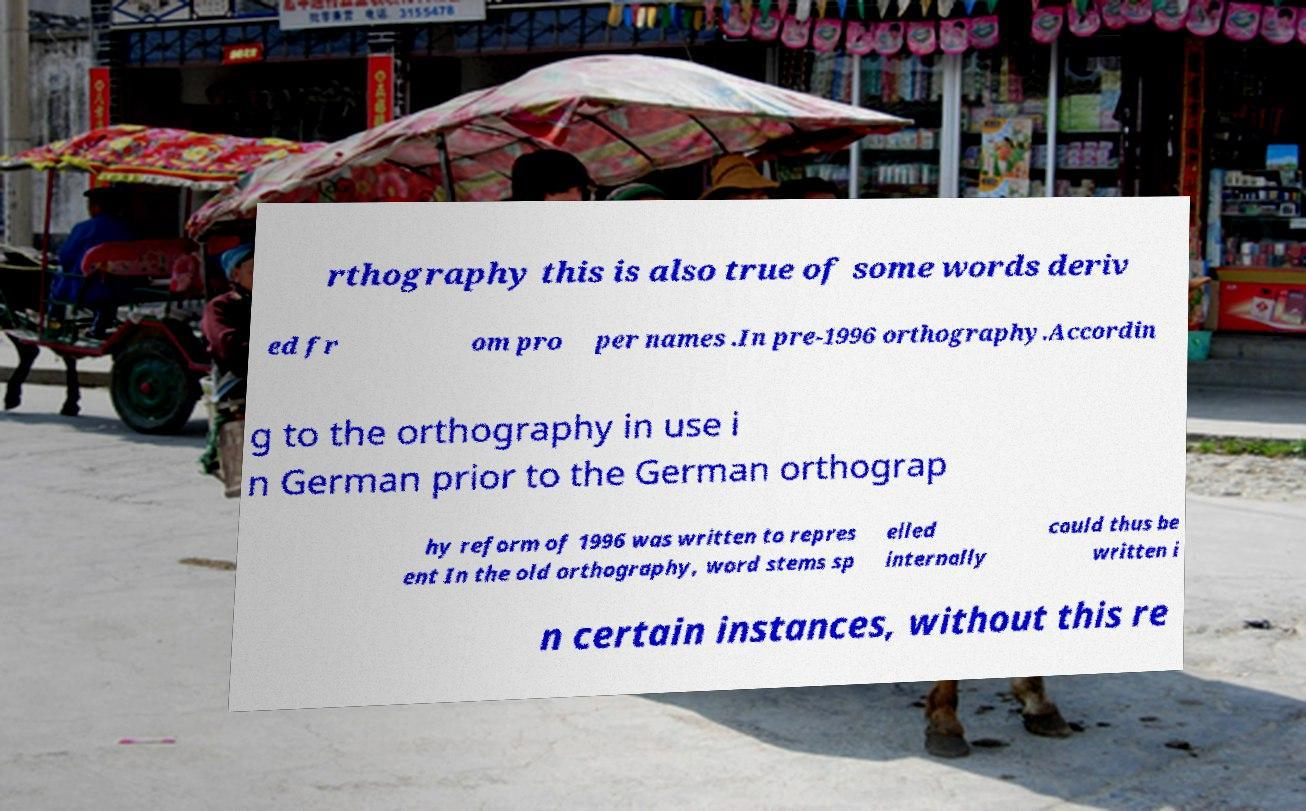Can you read and provide the text displayed in the image?This photo seems to have some interesting text. Can you extract and type it out for me? rthography this is also true of some words deriv ed fr om pro per names .In pre-1996 orthography.Accordin g to the orthography in use i n German prior to the German orthograp hy reform of 1996 was written to repres ent In the old orthography, word stems sp elled internally could thus be written i n certain instances, without this re 